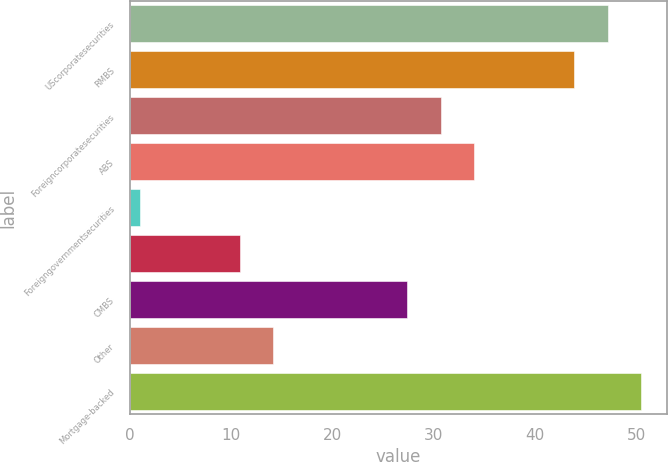<chart> <loc_0><loc_0><loc_500><loc_500><bar_chart><fcel>UScorporatesecurities<fcel>RMBS<fcel>Foreigncorporatesecurities<fcel>ABS<fcel>Foreigngovernmentsecurities<fcel>Unnamed: 5<fcel>CMBS<fcel>Other<fcel>Mortgage-backed<nl><fcel>47.2<fcel>43.9<fcel>30.7<fcel>34<fcel>1<fcel>10.9<fcel>27.4<fcel>14.2<fcel>50.5<nl></chart> 